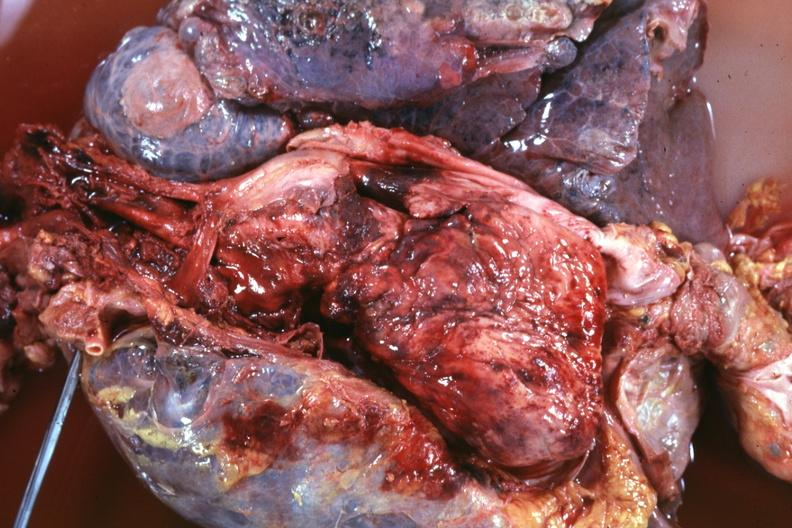s hematologic present?
Answer the question using a single word or phrase. Yes 